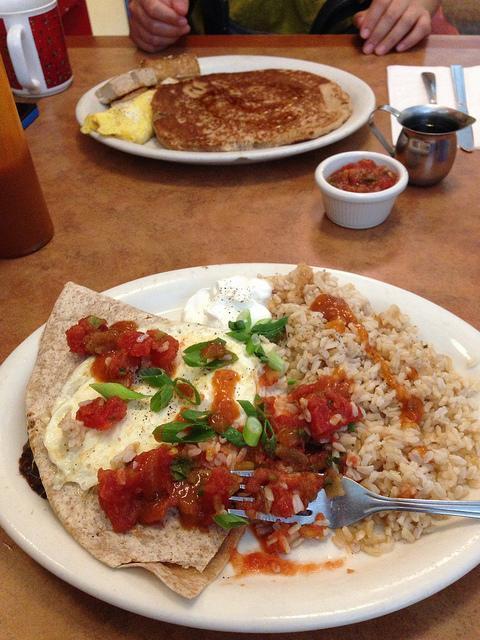What is the side dish on the plate in the foreground?
Select the correct answer and articulate reasoning with the following format: 'Answer: answer
Rationale: rationale.'
Options: Oranges, apple slices, rice, fries. Answer: rice.
Rationale: Rice is small grains which this food is. there are no fruits visible and no fries so this must be rice. 